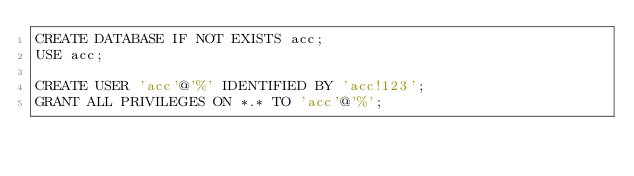Convert code to text. <code><loc_0><loc_0><loc_500><loc_500><_SQL_>CREATE DATABASE IF NOT EXISTS acc;
USE acc;

CREATE USER 'acc'@'%' IDENTIFIED BY 'acc!123';
GRANT ALL PRIVILEGES ON *.* TO 'acc'@'%';</code> 